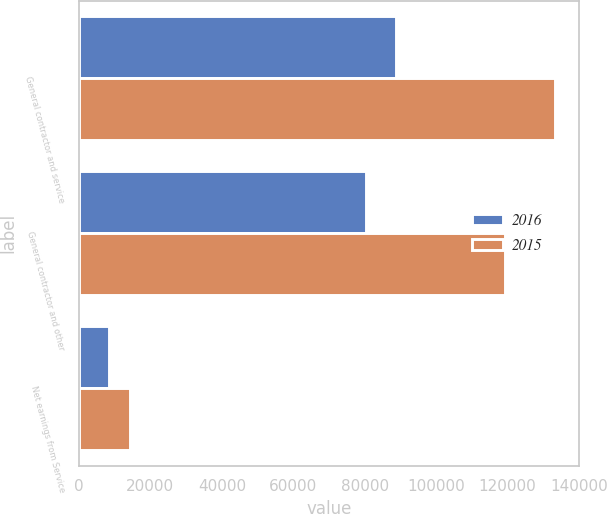<chart> <loc_0><loc_0><loc_500><loc_500><stacked_bar_chart><ecel><fcel>General contractor and service<fcel>General contractor and other<fcel>Net earnings from Service<nl><fcel>2016<fcel>88810<fcel>80467<fcel>8343<nl><fcel>2015<fcel>133367<fcel>119170<fcel>14197<nl></chart> 